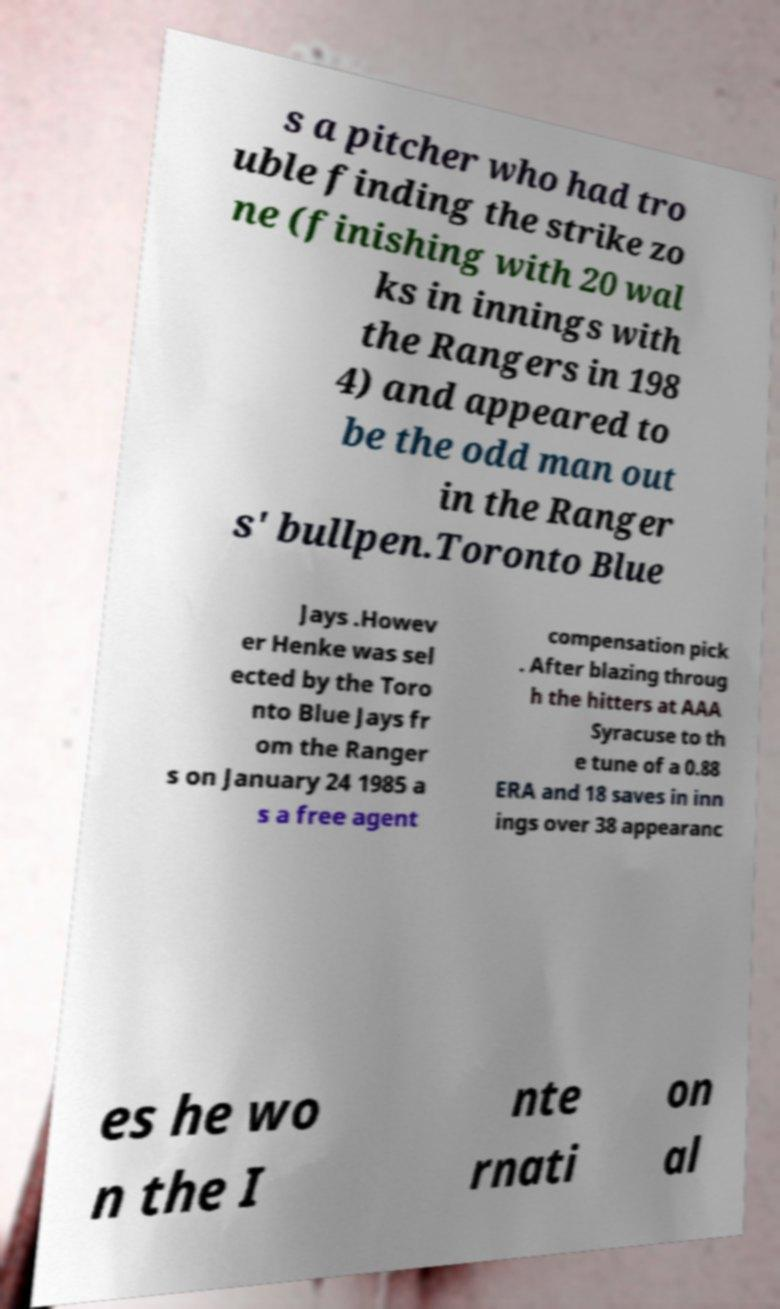Please read and relay the text visible in this image. What does it say? s a pitcher who had tro uble finding the strike zo ne (finishing with 20 wal ks in innings with the Rangers in 198 4) and appeared to be the odd man out in the Ranger s' bullpen.Toronto Blue Jays .Howev er Henke was sel ected by the Toro nto Blue Jays fr om the Ranger s on January 24 1985 a s a free agent compensation pick . After blazing throug h the hitters at AAA Syracuse to th e tune of a 0.88 ERA and 18 saves in inn ings over 38 appearanc es he wo n the I nte rnati on al 